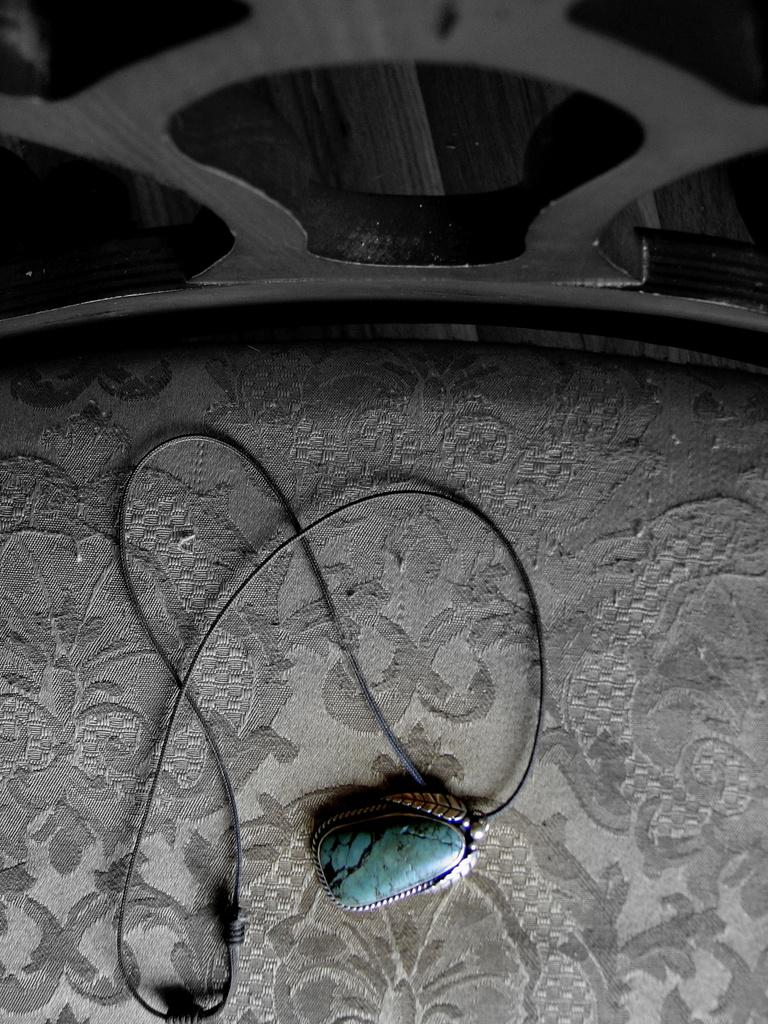What is the main object in the image? There is a chain with a pendant in the image. Where is the chain and pendant located? The chain and pendant are placed on the floor. What religious beliefs are represented by the pendant in the image? There is no indication of any religious beliefs in the image, as it only features a chain with a pendant placed on the floor. 